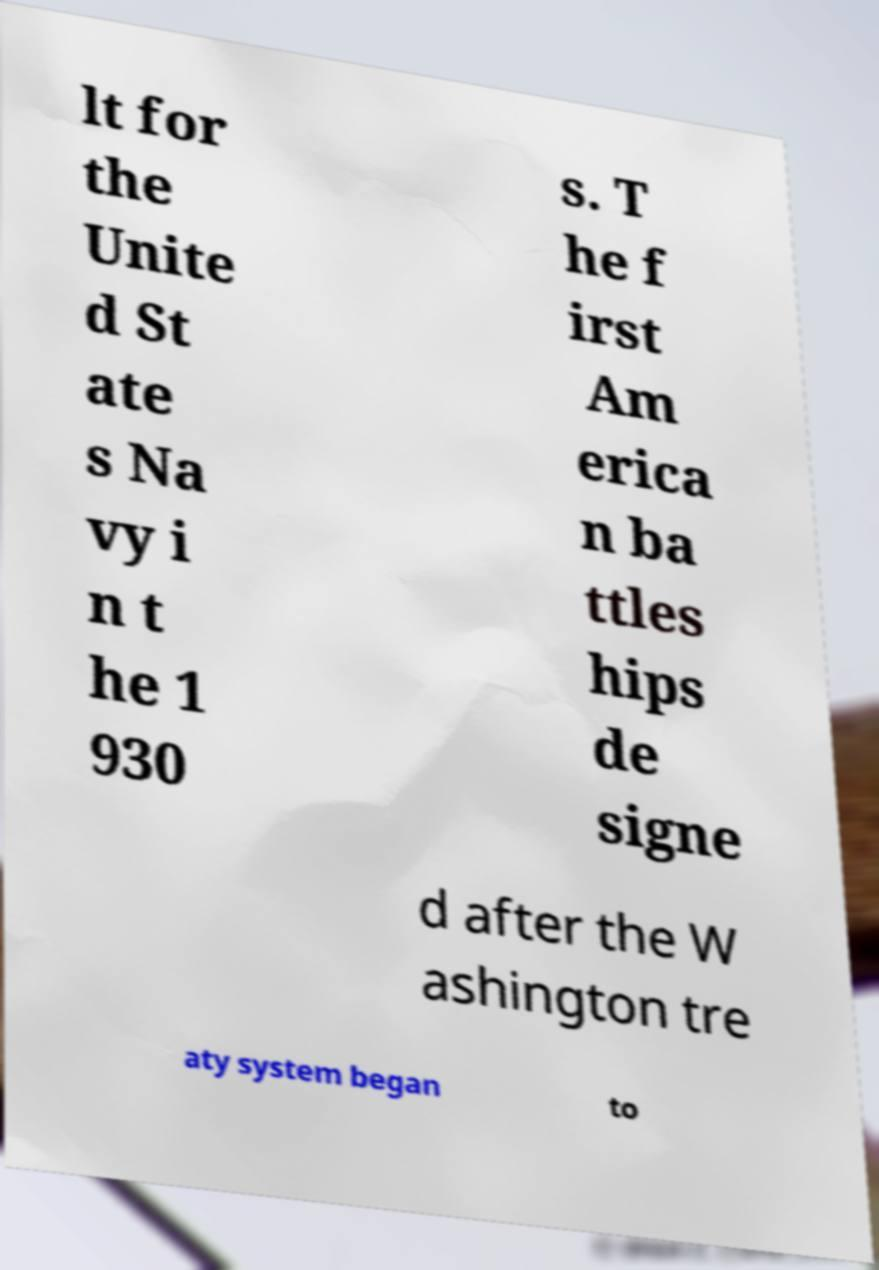There's text embedded in this image that I need extracted. Can you transcribe it verbatim? lt for the Unite d St ate s Na vy i n t he 1 930 s. T he f irst Am erica n ba ttles hips de signe d after the W ashington tre aty system began to 